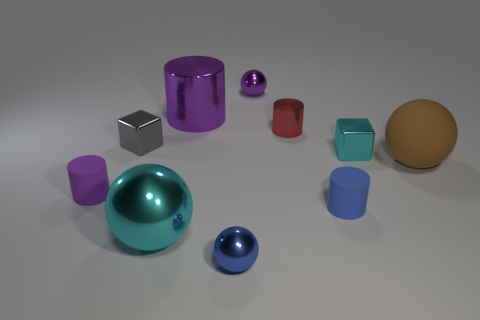Subtract all red metal cylinders. How many cylinders are left? 3 Subtract all red cylinders. How many cylinders are left? 3 Subtract all blue balls. How many purple cylinders are left? 2 Subtract 1 balls. How many balls are left? 3 Subtract all cubes. How many objects are left? 8 Subtract all tiny red metal objects. Subtract all purple matte cylinders. How many objects are left? 8 Add 4 shiny spheres. How many shiny spheres are left? 7 Add 9 tiny purple metallic spheres. How many tiny purple metallic spheres exist? 10 Subtract 0 cyan cylinders. How many objects are left? 10 Subtract all green blocks. Subtract all brown spheres. How many blocks are left? 2 